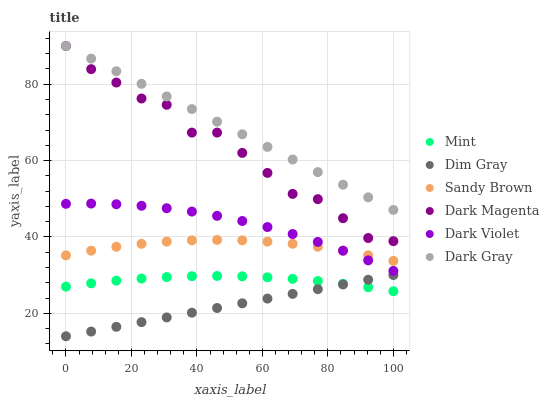Does Dim Gray have the minimum area under the curve?
Answer yes or no. Yes. Does Dark Gray have the maximum area under the curve?
Answer yes or no. Yes. Does Dark Magenta have the minimum area under the curve?
Answer yes or no. No. Does Dark Magenta have the maximum area under the curve?
Answer yes or no. No. Is Dim Gray the smoothest?
Answer yes or no. Yes. Is Dark Magenta the roughest?
Answer yes or no. Yes. Is Mint the smoothest?
Answer yes or no. No. Is Mint the roughest?
Answer yes or no. No. Does Dim Gray have the lowest value?
Answer yes or no. Yes. Does Dark Magenta have the lowest value?
Answer yes or no. No. Does Dark Gray have the highest value?
Answer yes or no. Yes. Does Mint have the highest value?
Answer yes or no. No. Is Sandy Brown less than Dark Magenta?
Answer yes or no. Yes. Is Dark Gray greater than Mint?
Answer yes or no. Yes. Does Dark Gray intersect Dark Magenta?
Answer yes or no. Yes. Is Dark Gray less than Dark Magenta?
Answer yes or no. No. Is Dark Gray greater than Dark Magenta?
Answer yes or no. No. Does Sandy Brown intersect Dark Magenta?
Answer yes or no. No. 